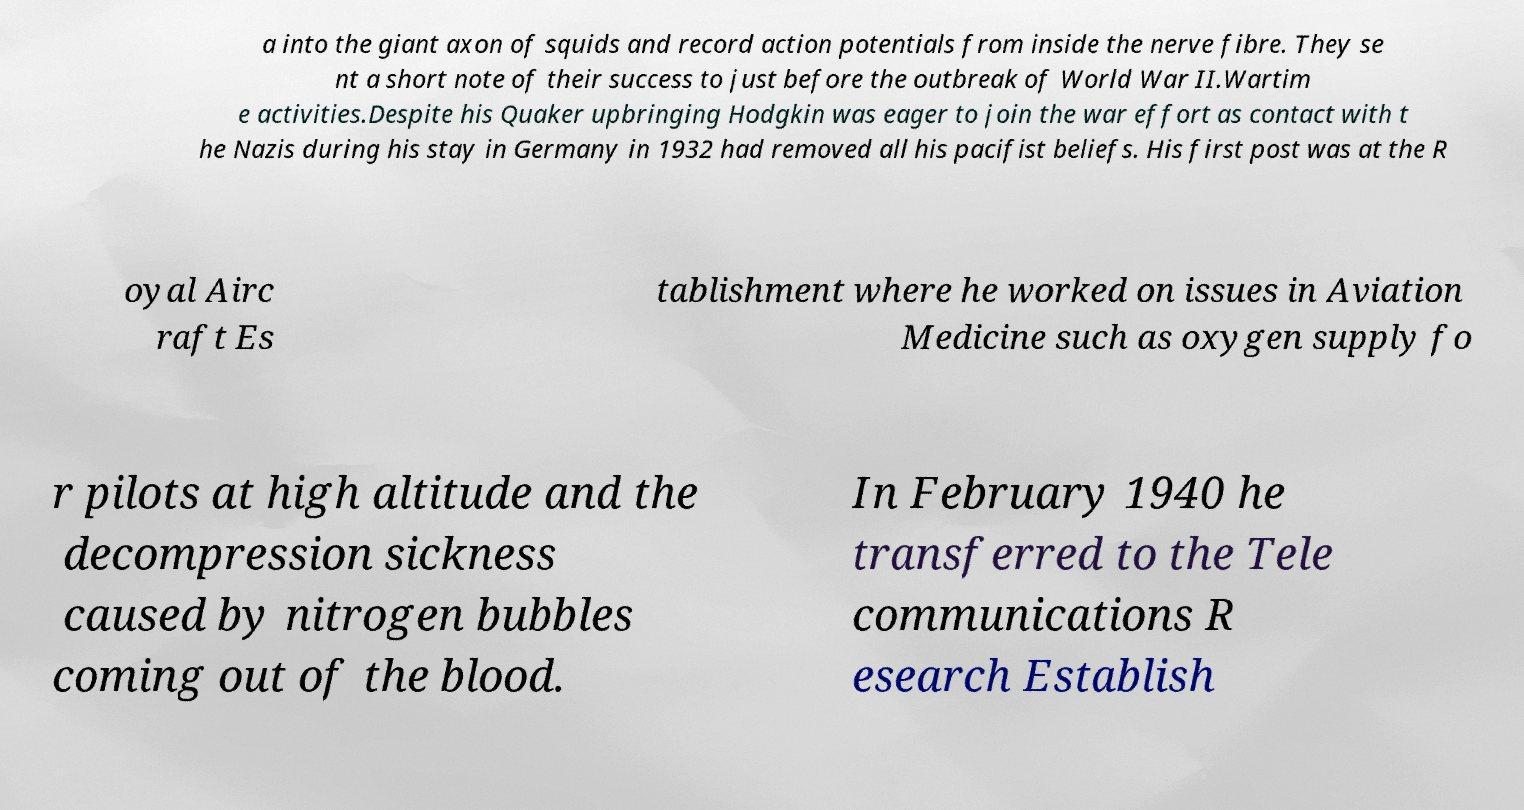For documentation purposes, I need the text within this image transcribed. Could you provide that? a into the giant axon of squids and record action potentials from inside the nerve fibre. They se nt a short note of their success to just before the outbreak of World War II.Wartim e activities.Despite his Quaker upbringing Hodgkin was eager to join the war effort as contact with t he Nazis during his stay in Germany in 1932 had removed all his pacifist beliefs. His first post was at the R oyal Airc raft Es tablishment where he worked on issues in Aviation Medicine such as oxygen supply fo r pilots at high altitude and the decompression sickness caused by nitrogen bubbles coming out of the blood. In February 1940 he transferred to the Tele communications R esearch Establish 